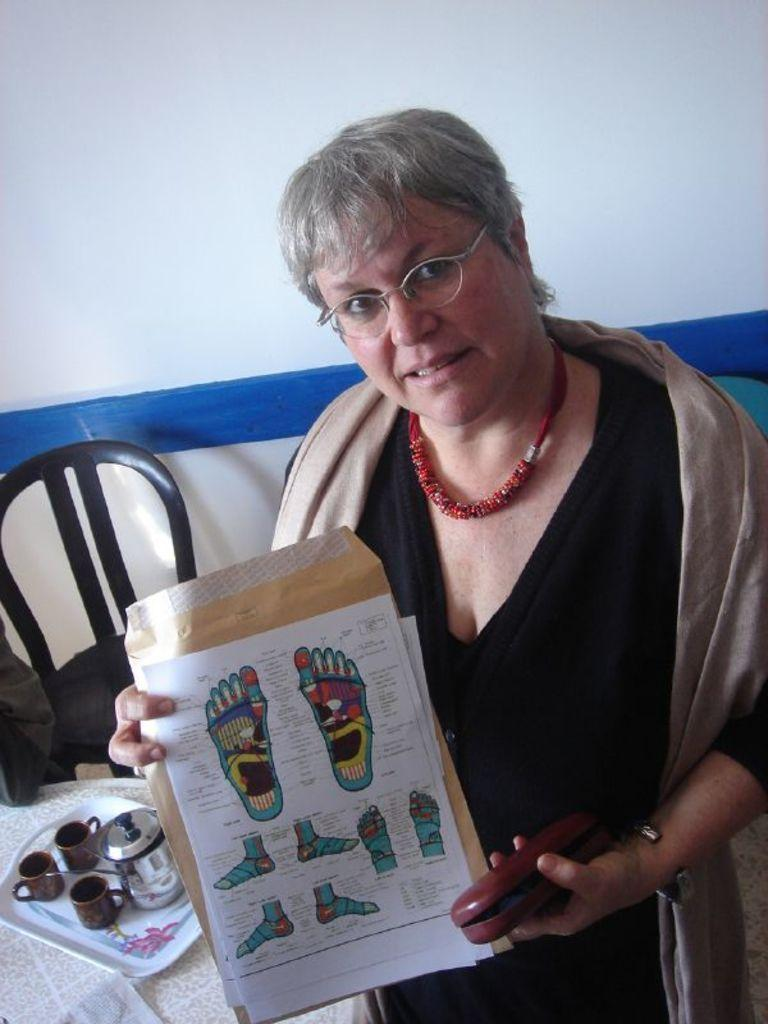Who is the main subject in the image? There is a lady in the image. Where is the lady positioned in the image? The lady is standing on the right side of the image. What is the lady holding in her hand? The lady is holding a poster in her hand. What furniture can be seen in the image? There is a table and a chair in the image. What type of orange texture can be seen on the map in the image? There is no orange texture or map present in the image. 